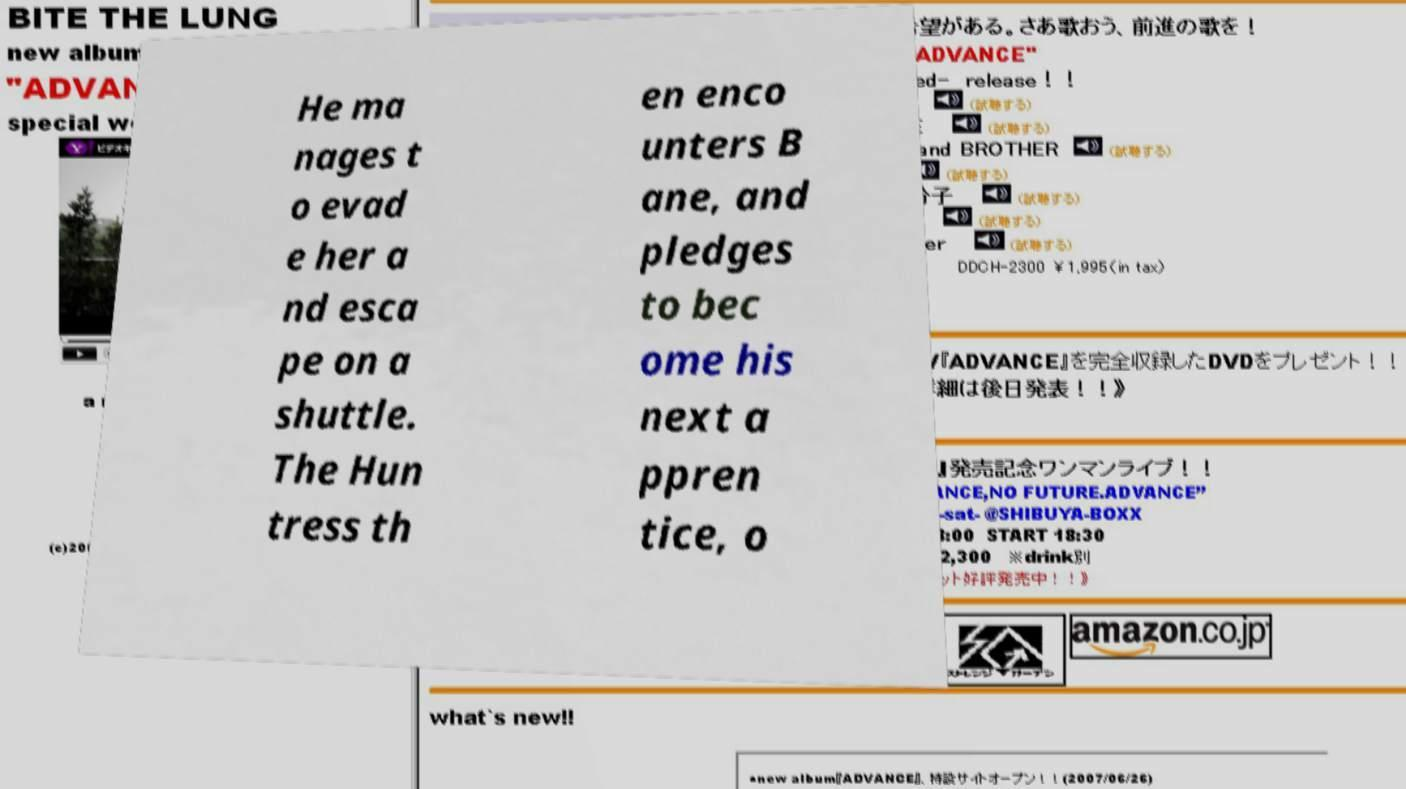For documentation purposes, I need the text within this image transcribed. Could you provide that? He ma nages t o evad e her a nd esca pe on a shuttle. The Hun tress th en enco unters B ane, and pledges to bec ome his next a ppren tice, o 